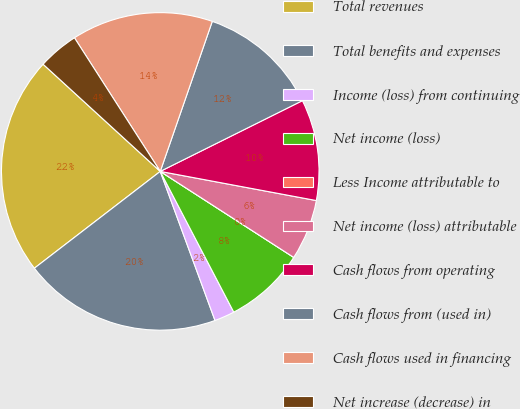Convert chart. <chart><loc_0><loc_0><loc_500><loc_500><pie_chart><fcel>Total revenues<fcel>Total benefits and expenses<fcel>Income (loss) from continuing<fcel>Net income (loss)<fcel>Less Income attributable to<fcel>Net income (loss) attributable<fcel>Cash flows from operating<fcel>Cash flows from (used in)<fcel>Cash flows used in financing<fcel>Net increase (decrease) in<nl><fcel>22.23%<fcel>20.17%<fcel>2.06%<fcel>8.23%<fcel>0.0%<fcel>6.17%<fcel>10.29%<fcel>12.34%<fcel>14.4%<fcel>4.12%<nl></chart> 